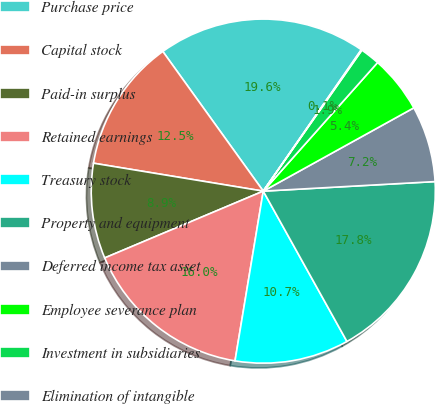<chart> <loc_0><loc_0><loc_500><loc_500><pie_chart><fcel>Purchase price<fcel>Capital stock<fcel>Paid-in surplus<fcel>Retained earnings<fcel>Treasury stock<fcel>Property and equipment<fcel>Deferred income tax asset<fcel>Employee severance plan<fcel>Investment in subsidiaries<fcel>Elimination of intangible<nl><fcel>19.57%<fcel>12.48%<fcel>8.94%<fcel>16.03%<fcel>10.71%<fcel>17.8%<fcel>7.16%<fcel>5.39%<fcel>1.85%<fcel>0.07%<nl></chart> 